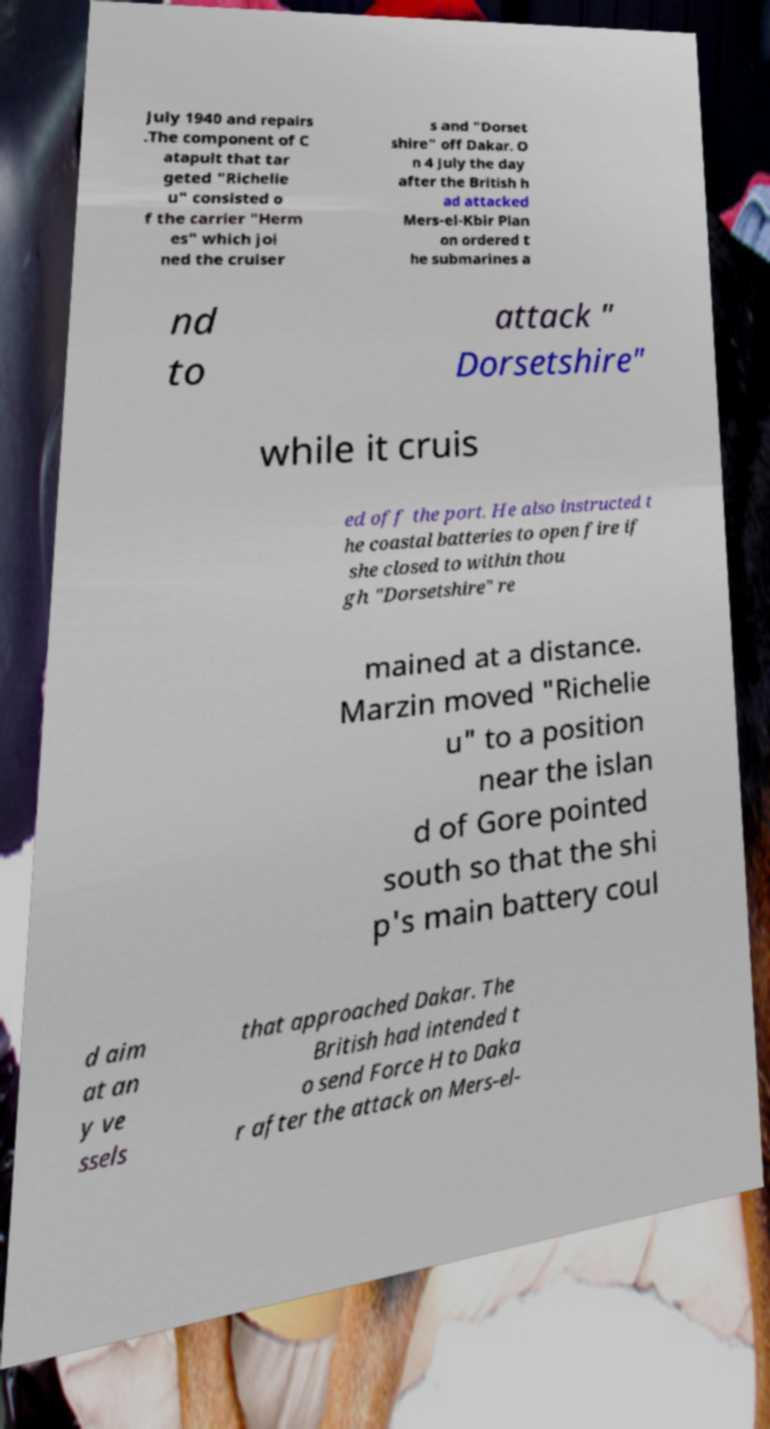What messages or text are displayed in this image? I need them in a readable, typed format. July 1940 and repairs .The component of C atapult that tar geted "Richelie u" consisted o f the carrier "Herm es" which joi ned the cruiser s and "Dorset shire" off Dakar. O n 4 July the day after the British h ad attacked Mers-el-Kbir Plan on ordered t he submarines a nd to attack " Dorsetshire" while it cruis ed off the port. He also instructed t he coastal batteries to open fire if she closed to within thou gh "Dorsetshire" re mained at a distance. Marzin moved "Richelie u" to a position near the islan d of Gore pointed south so that the shi p's main battery coul d aim at an y ve ssels that approached Dakar. The British had intended t o send Force H to Daka r after the attack on Mers-el- 